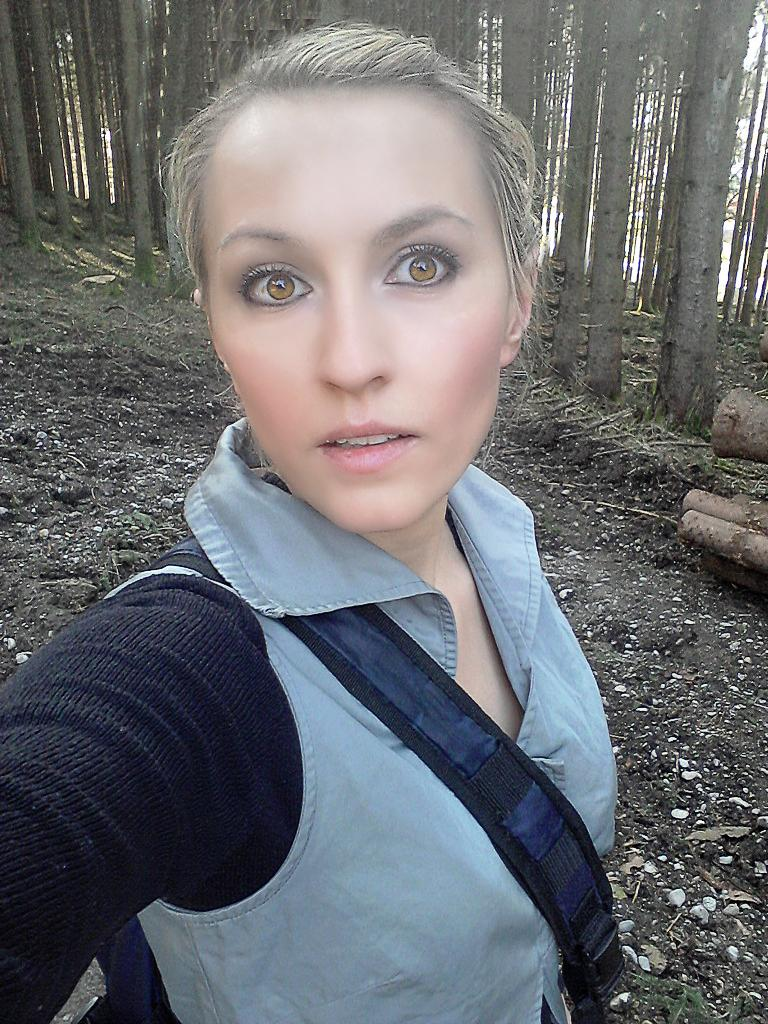Who is present in the image? There is a woman in the image. What can be seen in the background of the image? There are trees in the background of the image. What page of the notebook is the woman writing on in the image? There is no notebook present in the image, so it is not possible to determine which page the woman might be writing on. 